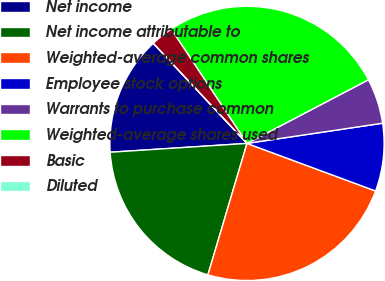Convert chart. <chart><loc_0><loc_0><loc_500><loc_500><pie_chart><fcel>Net income<fcel>Net income attributable to<fcel>Weighted-average common shares<fcel>Employee stock options<fcel>Warrants to purchase common<fcel>Weighted-average shares used<fcel>Basic<fcel>Diluted<nl><fcel>14.05%<fcel>19.37%<fcel>23.96%<fcel>7.99%<fcel>5.33%<fcel>26.63%<fcel>2.66%<fcel>0.0%<nl></chart> 